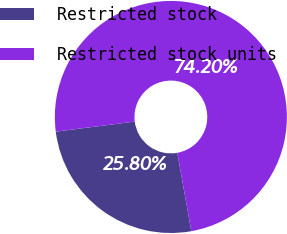Convert chart. <chart><loc_0><loc_0><loc_500><loc_500><pie_chart><fcel>Restricted stock<fcel>Restricted stock units<nl><fcel>25.8%<fcel>74.2%<nl></chart> 